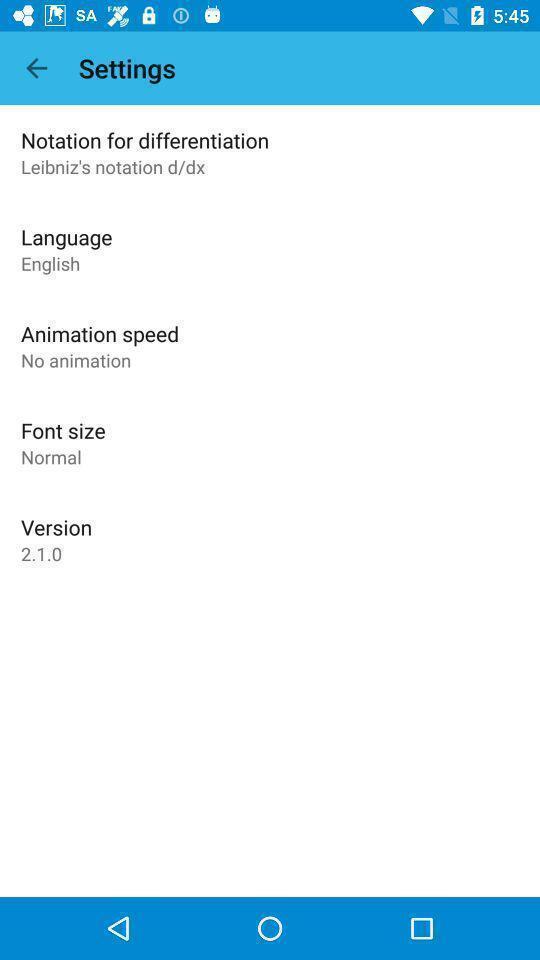Give me a narrative description of this picture. Settings page. 